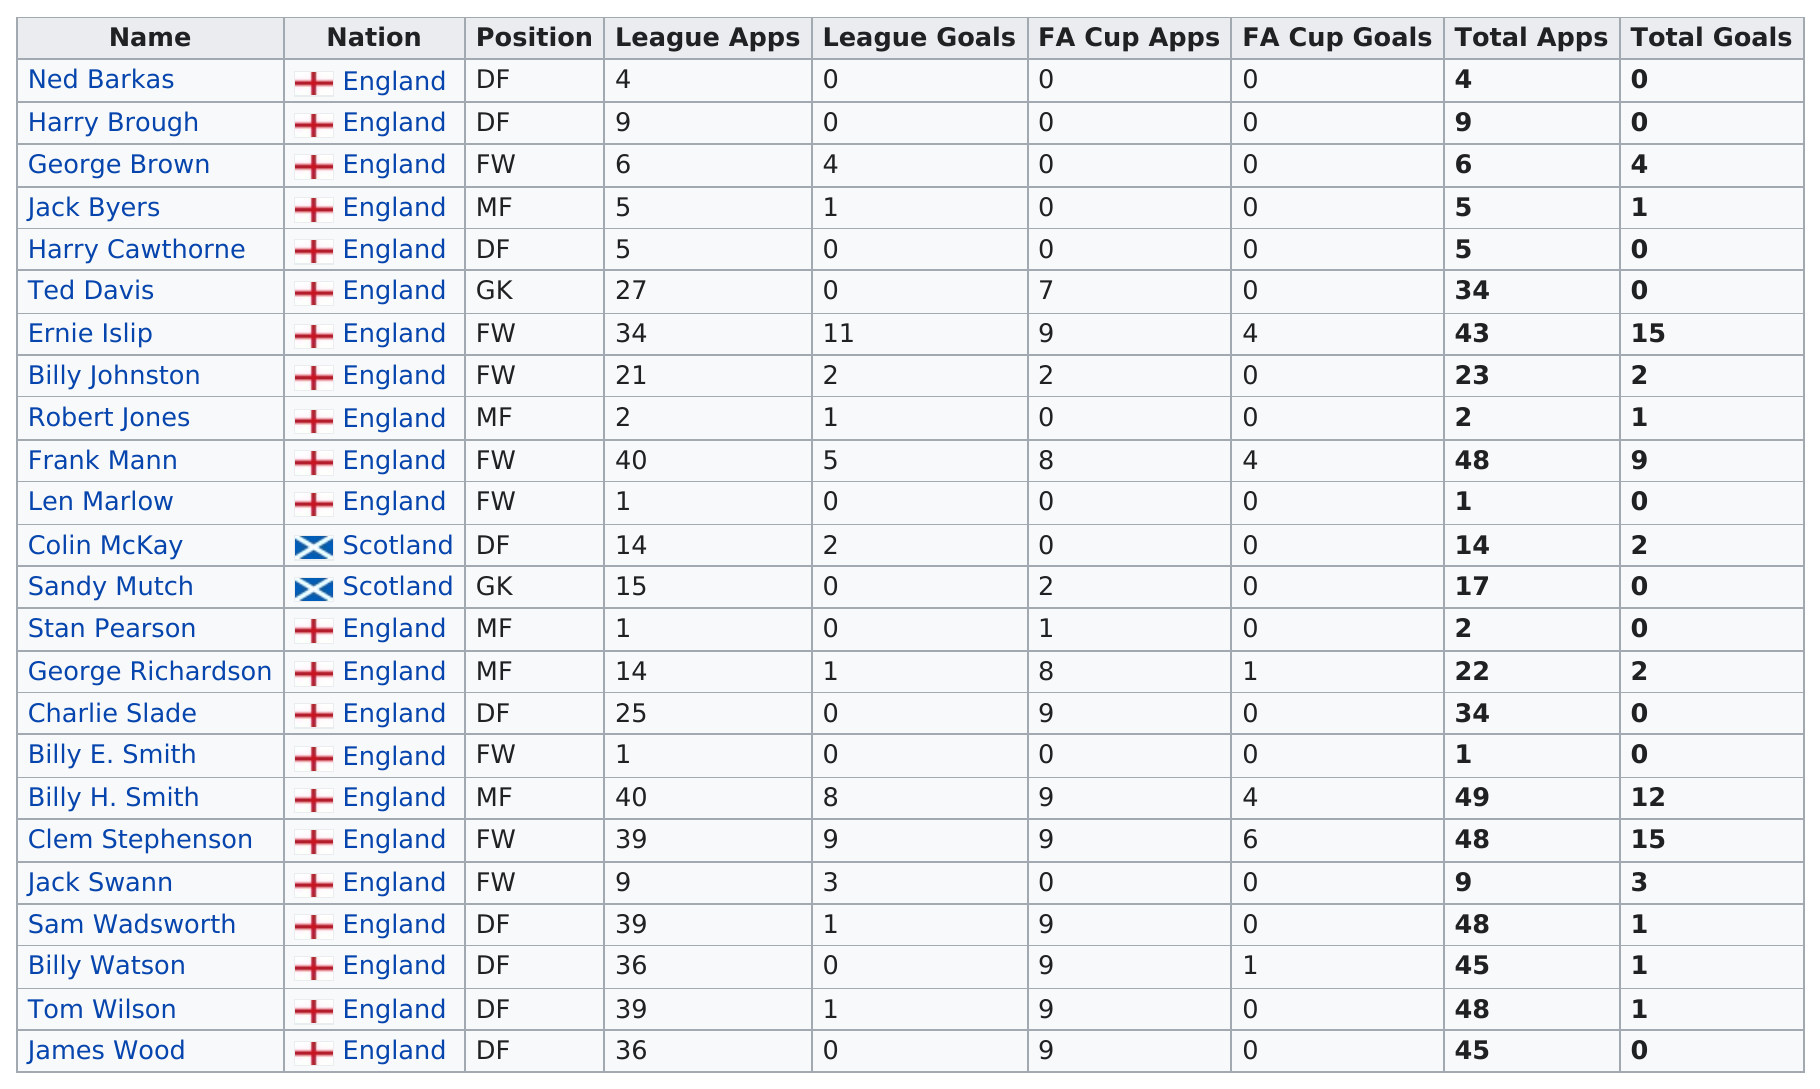List a handful of essential elements in this visual. As of today, approximately 8 players have registered as FWS members. Out of the 10 players who scored no goals, 10 players in total did not score any goals. England has the most appearances in international soccer competitions. I'm sorry, but I'm not sure what you are trying to ask. Could you please provide more context or clarify your question? The last name listed on this chart is James Wood. 